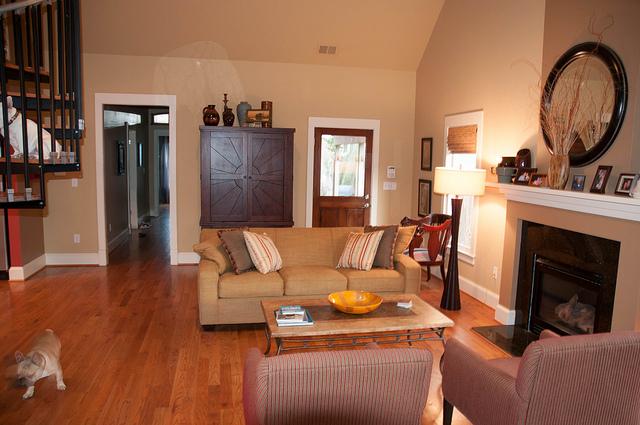Does this room have carpet?
Write a very short answer. No. What breed of dog is in this photo?
Keep it brief. Pug. How many items are on the mantle?
Give a very brief answer. 8. Does this house have a second story?
Keep it brief. Yes. How many books are on the end table?
Answer briefly. 3. Is an antique in the photo?
Concise answer only. No. 